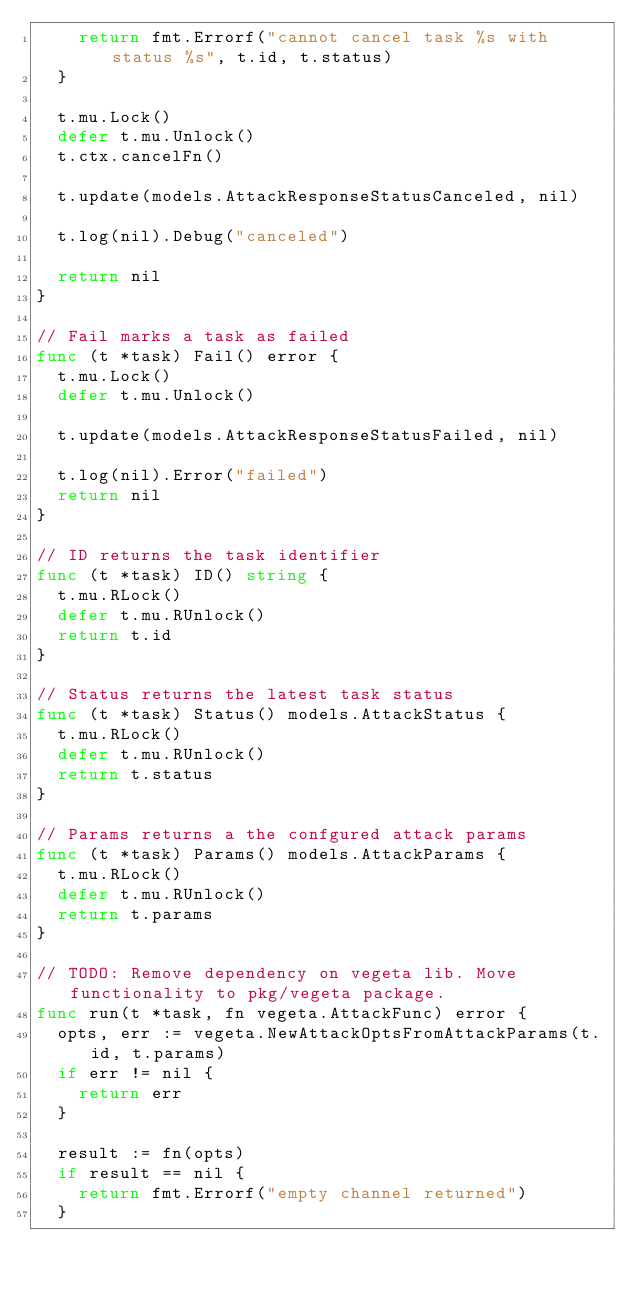<code> <loc_0><loc_0><loc_500><loc_500><_Go_>		return fmt.Errorf("cannot cancel task %s with status %s", t.id, t.status)
	}

	t.mu.Lock()
	defer t.mu.Unlock()
	t.ctx.cancelFn()

	t.update(models.AttackResponseStatusCanceled, nil)

	t.log(nil).Debug("canceled")

	return nil
}

// Fail marks a task as failed
func (t *task) Fail() error {
	t.mu.Lock()
	defer t.mu.Unlock()

	t.update(models.AttackResponseStatusFailed, nil)

	t.log(nil).Error("failed")
	return nil
}

// ID returns the task identifier
func (t *task) ID() string {
	t.mu.RLock()
	defer t.mu.RUnlock()
	return t.id
}

// Status returns the latest task status
func (t *task) Status() models.AttackStatus {
	t.mu.RLock()
	defer t.mu.RUnlock()
	return t.status
}

// Params returns a the confgured attack params
func (t *task) Params() models.AttackParams {
	t.mu.RLock()
	defer t.mu.RUnlock()
	return t.params
}

// TODO: Remove dependency on vegeta lib. Move functionality to pkg/vegeta package.
func run(t *task, fn vegeta.AttackFunc) error {
	opts, err := vegeta.NewAttackOptsFromAttackParams(t.id, t.params)
	if err != nil {
		return err
	}

	result := fn(opts)
	if result == nil {
		return fmt.Errorf("empty channel returned")
	}
</code> 